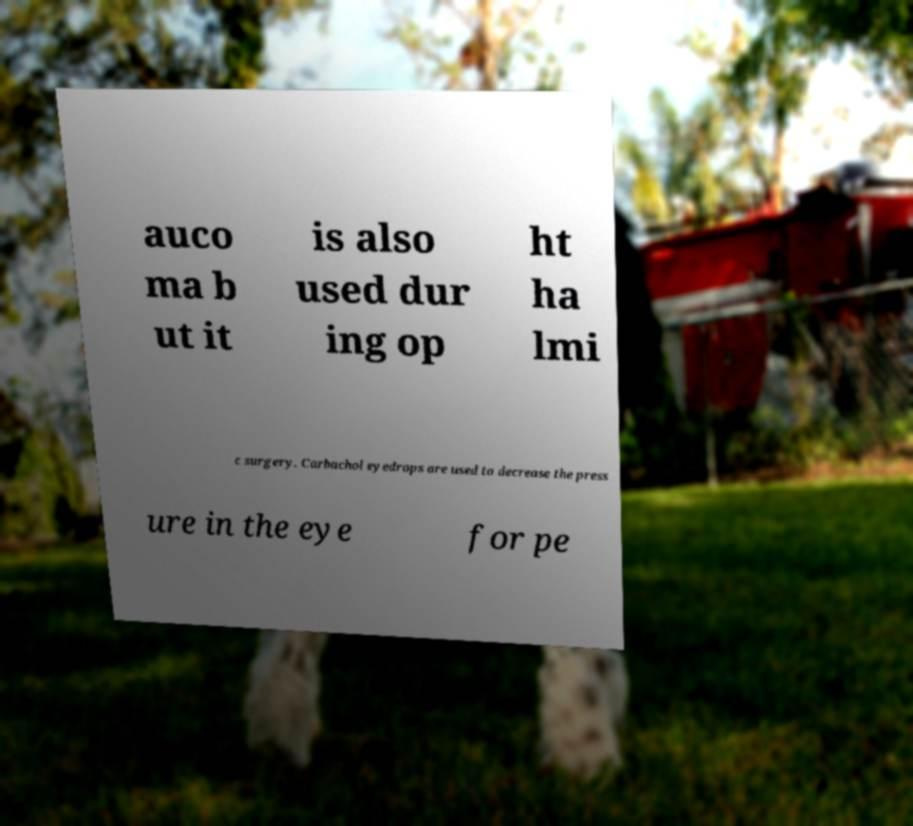Can you read and provide the text displayed in the image?This photo seems to have some interesting text. Can you extract and type it out for me? auco ma b ut it is also used dur ing op ht ha lmi c surgery. Carbachol eyedrops are used to decrease the press ure in the eye for pe 